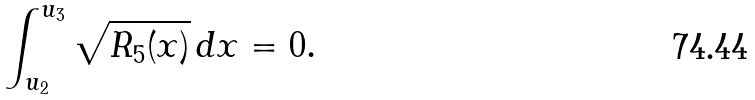Convert formula to latex. <formula><loc_0><loc_0><loc_500><loc_500>\int _ { u _ { 2 } } ^ { u _ { 3 } } \sqrt { R _ { 5 } ( x ) } \, d x = 0 .</formula> 